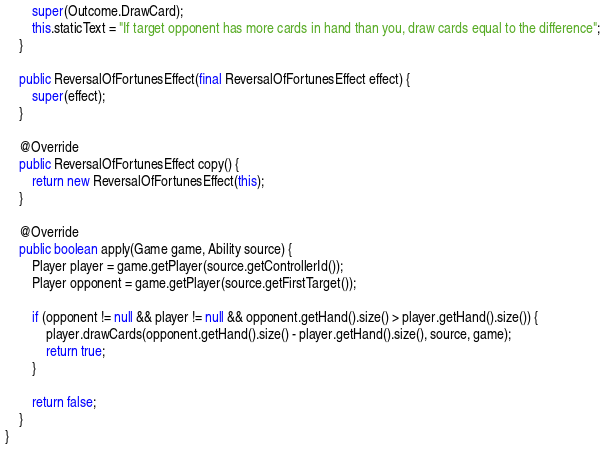<code> <loc_0><loc_0><loc_500><loc_500><_Java_>        super(Outcome.DrawCard);
        this.staticText = "If target opponent has more cards in hand than you, draw cards equal to the difference";
    }

    public ReversalOfFortunesEffect(final ReversalOfFortunesEffect effect) {
        super(effect);
    }

    @Override
    public ReversalOfFortunesEffect copy() {
        return new ReversalOfFortunesEffect(this);
    }

    @Override
    public boolean apply(Game game, Ability source) {
        Player player = game.getPlayer(source.getControllerId());
        Player opponent = game.getPlayer(source.getFirstTarget());

        if (opponent != null && player != null && opponent.getHand().size() > player.getHand().size()) {
            player.drawCards(opponent.getHand().size() - player.getHand().size(), source, game);
            return true;
        }

        return false;
    }
}
</code> 